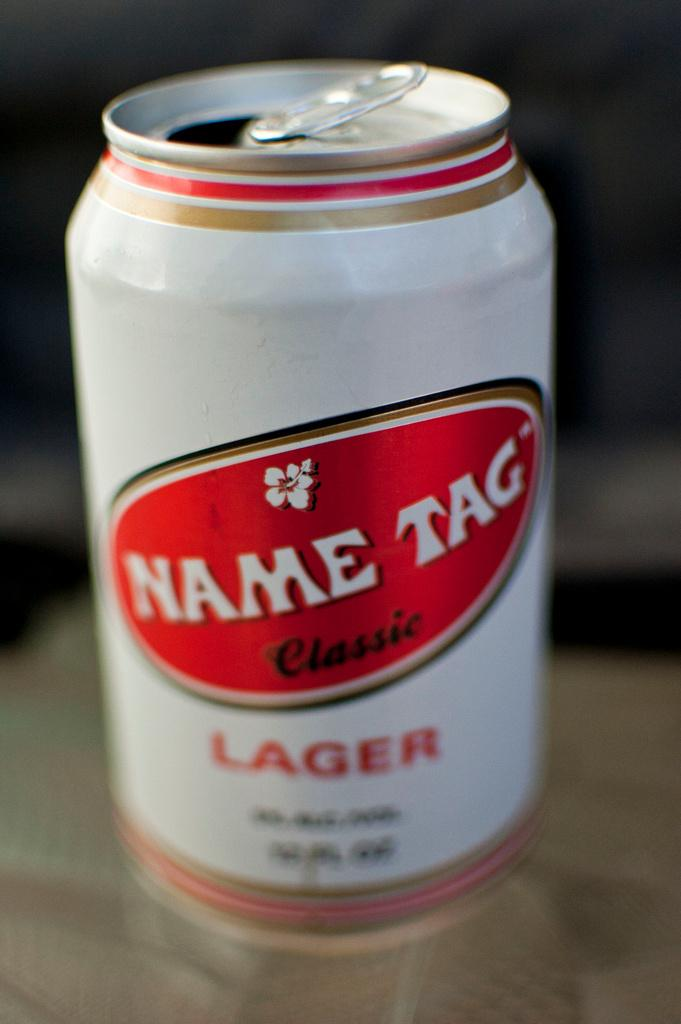<image>
Relay a brief, clear account of the picture shown. A can of lager is branded "Name Tag Classic." 